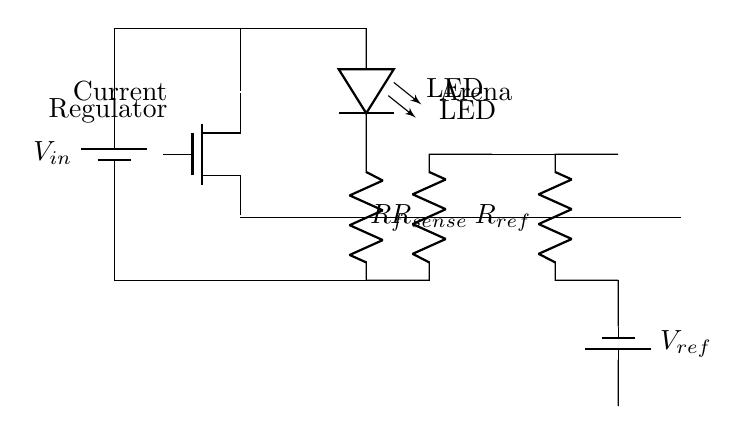What is the input voltage of this circuit? The input voltage is represented by \( V_{in} \), which is indicated by the battery symbol at the beginning of the circuit diagram.
Answer: \( V_{in} \) What type of transistor is used in this circuit? The transistor used in the circuit is a MOSFET, which is represented in the diagram by the node labeled as 'nmos'.
Answer: MOSFET What component is placed in series with the LED? The component in series with the LED is a current sense resistor labeled as \( R_{sense} \), connected directly below the LED to measure the current passing through it.
Answer: Current sense resistor What does the feedback loop with the op-amp control? The feedback loop with the op-amp controls the output current flowing to the LED, ensuring that it remains at the desired level by comparing the voltage across \( R_{sense} \) to the reference voltage.
Answer: Output current level What is the purpose of the reference voltage in this circuit? The reference voltage, indicated by \( V_{ref} \), is used by the op-amp to stabilize the current driving the LED by providing a set point for the current regulation.
Answer: Stabilize current How does the op-amp influence the MOSFET operation? The op-amp's output is connected to the gate of the MOSFET; it adjusts the MOSFET’s gate voltage based on the feedback from \( R_{sense} \), thereby controlling the current flowing to the LED and maintaining desired brightness.
Answer: Control LED brightness 